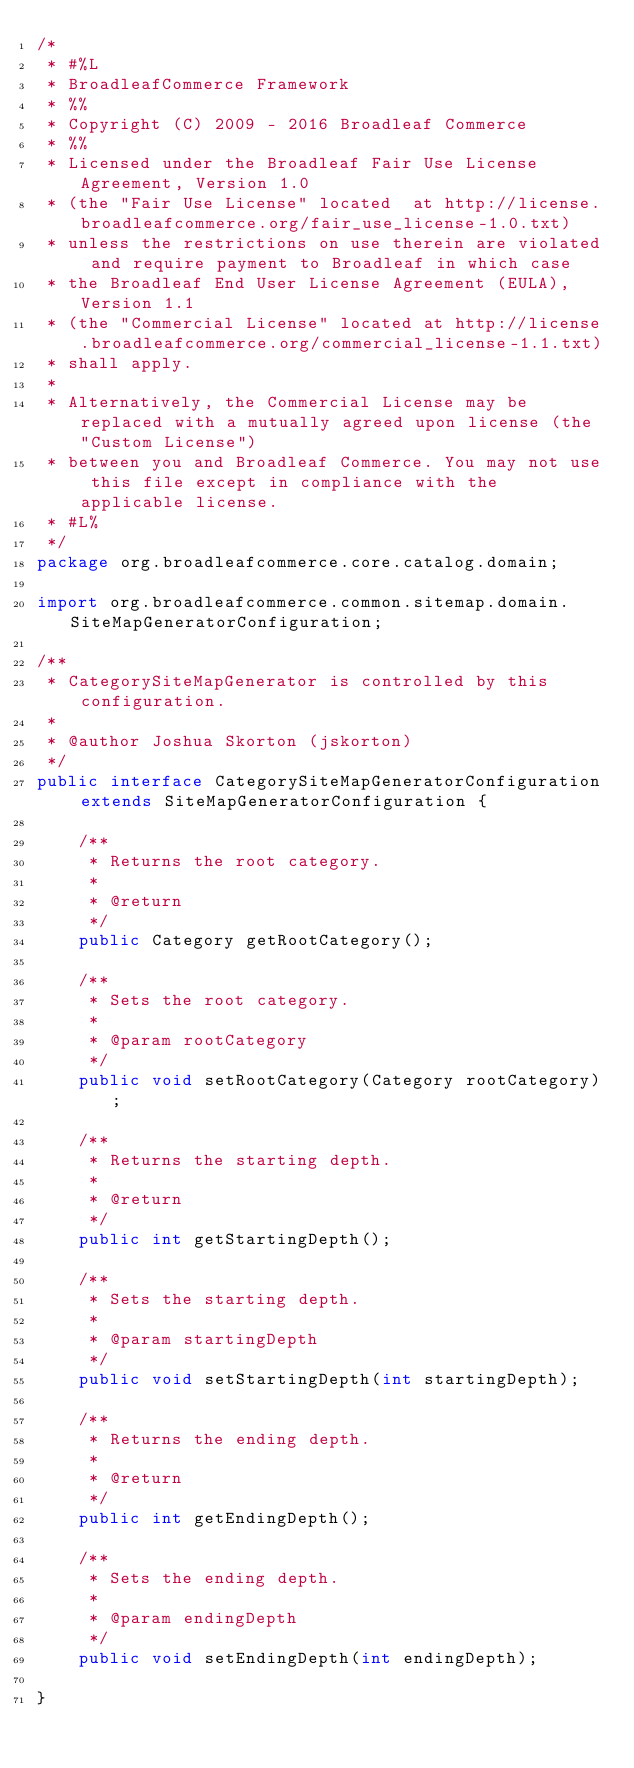Convert code to text. <code><loc_0><loc_0><loc_500><loc_500><_Java_>/*
 * #%L
 * BroadleafCommerce Framework
 * %%
 * Copyright (C) 2009 - 2016 Broadleaf Commerce
 * %%
 * Licensed under the Broadleaf Fair Use License Agreement, Version 1.0
 * (the "Fair Use License" located  at http://license.broadleafcommerce.org/fair_use_license-1.0.txt)
 * unless the restrictions on use therein are violated and require payment to Broadleaf in which case
 * the Broadleaf End User License Agreement (EULA), Version 1.1
 * (the "Commercial License" located at http://license.broadleafcommerce.org/commercial_license-1.1.txt)
 * shall apply.
 * 
 * Alternatively, the Commercial License may be replaced with a mutually agreed upon license (the "Custom License")
 * between you and Broadleaf Commerce. You may not use this file except in compliance with the applicable license.
 * #L%
 */
package org.broadleafcommerce.core.catalog.domain;

import org.broadleafcommerce.common.sitemap.domain.SiteMapGeneratorConfiguration;

/**
 * CategorySiteMapGenerator is controlled by this configuration.
 * 
 * @author Joshua Skorton (jskorton)
 */
public interface CategorySiteMapGeneratorConfiguration extends SiteMapGeneratorConfiguration {

    /**
     * Returns the root category.
     * 
     * @return
     */
    public Category getRootCategory();

    /**
     * Sets the root category.
     * 
     * @param rootCategory
     */
    public void setRootCategory(Category rootCategory);

    /**
     * Returns the starting depth.
     * 
     * @return
     */
    public int getStartingDepth();

    /**
     * Sets the starting depth.
     * 
     * @param startingDepth
     */
    public void setStartingDepth(int startingDepth);

    /**
     * Returns the ending depth.
     * 
     * @return
     */
    public int getEndingDepth();

    /**
     * Sets the ending depth.
     * 
     * @param endingDepth
     */
    public void setEndingDepth(int endingDepth);

}
</code> 